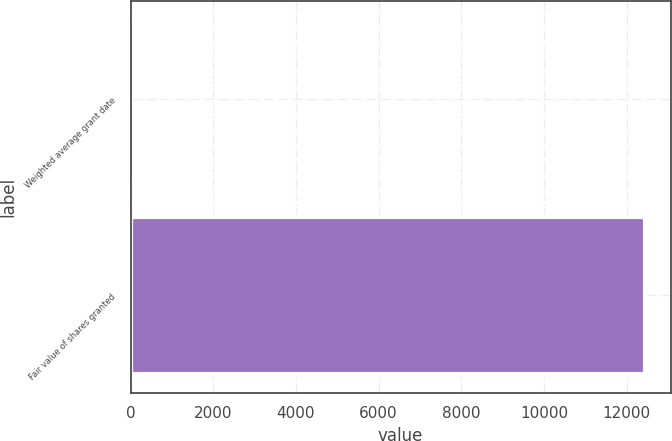<chart> <loc_0><loc_0><loc_500><loc_500><bar_chart><fcel>Weighted average grant date<fcel>Fair value of shares granted<nl><fcel>25.98<fcel>12444<nl></chart> 